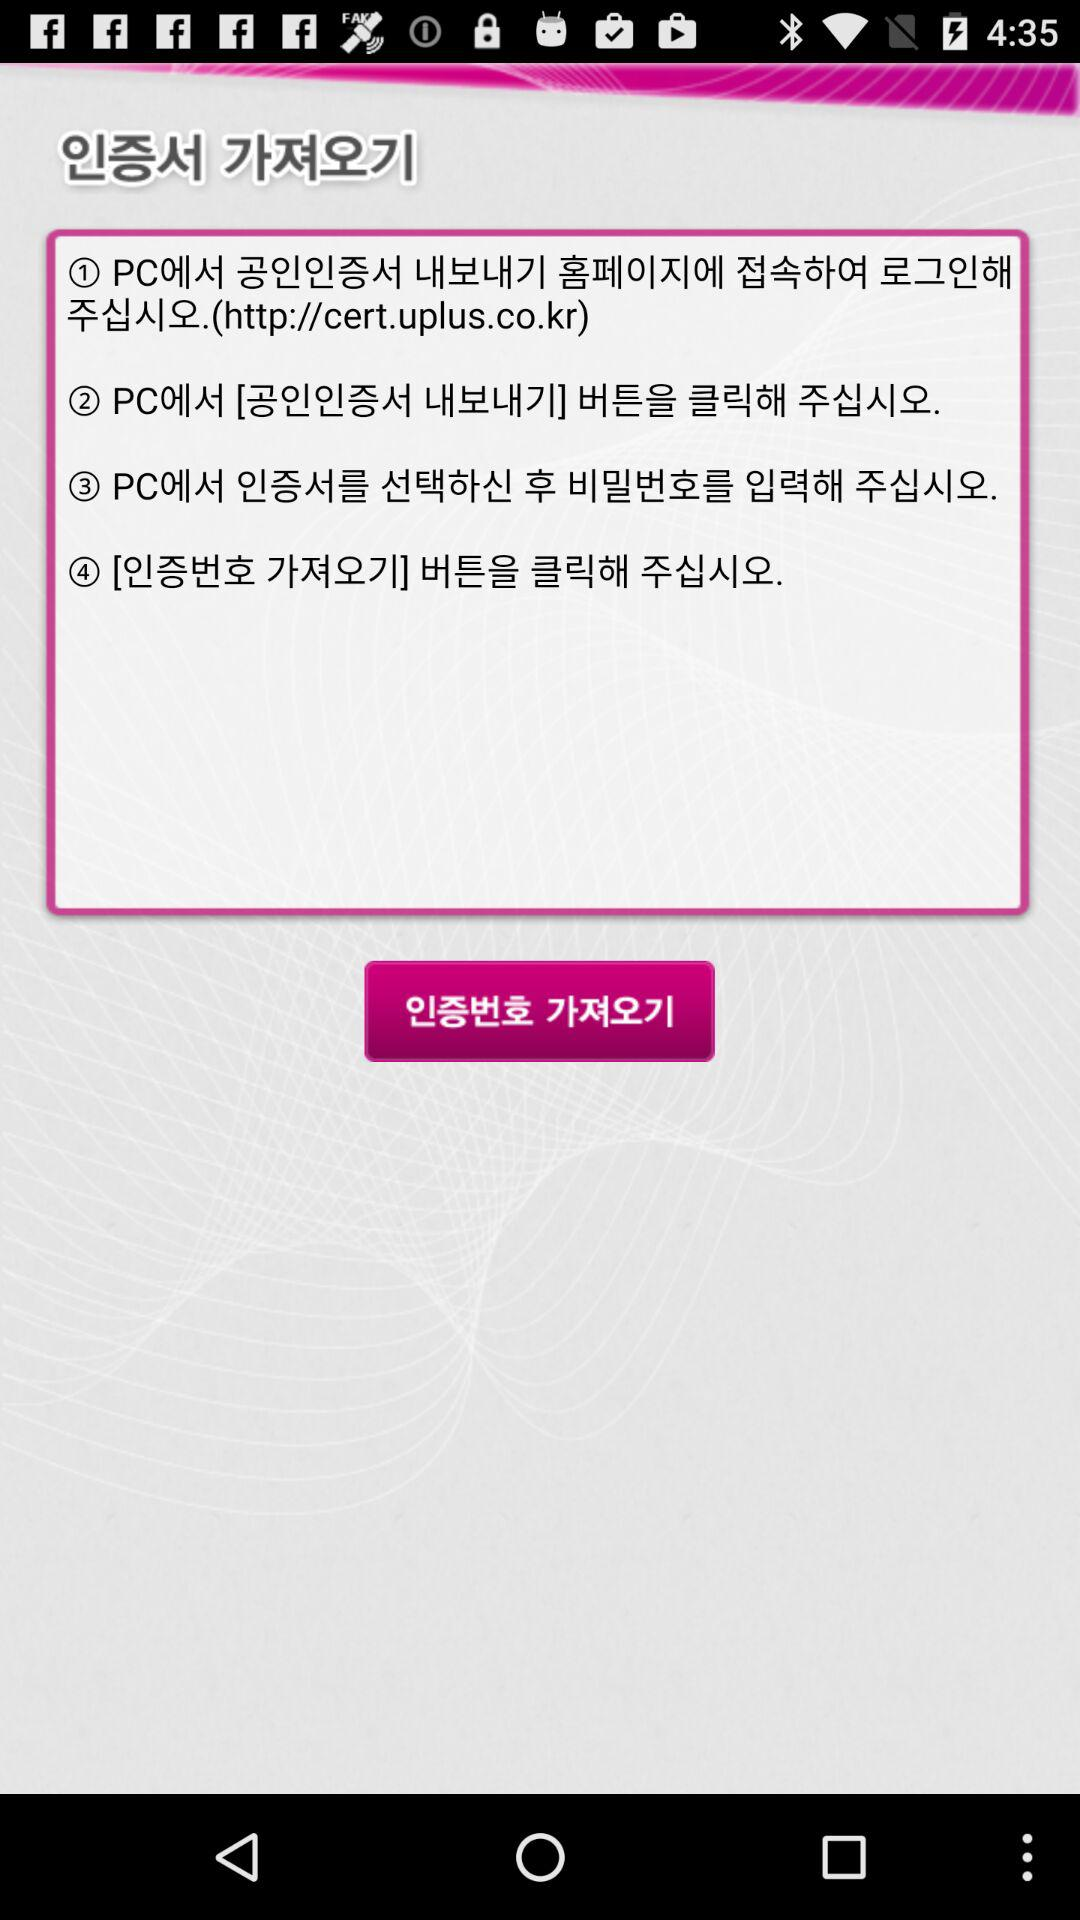How many steps are there in the process?
Answer the question using a single word or phrase. 4 